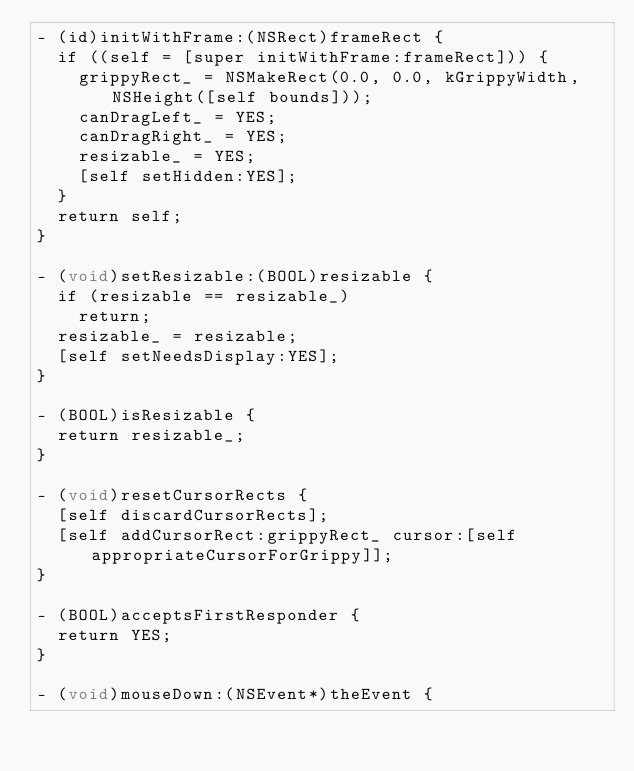<code> <loc_0><loc_0><loc_500><loc_500><_ObjectiveC_>- (id)initWithFrame:(NSRect)frameRect {
  if ((self = [super initWithFrame:frameRect])) {
    grippyRect_ = NSMakeRect(0.0, 0.0, kGrippyWidth, NSHeight([self bounds]));
    canDragLeft_ = YES;
    canDragRight_ = YES;
    resizable_ = YES;
    [self setHidden:YES];
  }
  return self;
}

- (void)setResizable:(BOOL)resizable {
  if (resizable == resizable_)
    return;
  resizable_ = resizable;
  [self setNeedsDisplay:YES];
}

- (BOOL)isResizable {
  return resizable_;
}

- (void)resetCursorRects {
  [self discardCursorRects];
  [self addCursorRect:grippyRect_ cursor:[self appropriateCursorForGrippy]];
}

- (BOOL)acceptsFirstResponder {
  return YES;
}

- (void)mouseDown:(NSEvent*)theEvent {</code> 